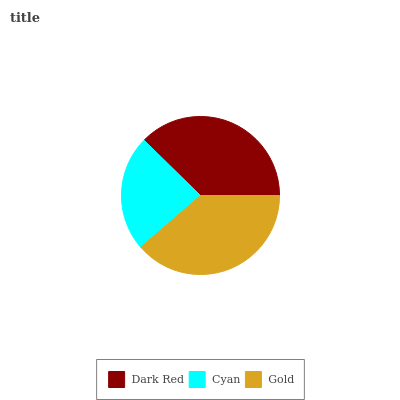Is Cyan the minimum?
Answer yes or no. Yes. Is Gold the maximum?
Answer yes or no. Yes. Is Gold the minimum?
Answer yes or no. No. Is Cyan the maximum?
Answer yes or no. No. Is Gold greater than Cyan?
Answer yes or no. Yes. Is Cyan less than Gold?
Answer yes or no. Yes. Is Cyan greater than Gold?
Answer yes or no. No. Is Gold less than Cyan?
Answer yes or no. No. Is Dark Red the high median?
Answer yes or no. Yes. Is Dark Red the low median?
Answer yes or no. Yes. Is Gold the high median?
Answer yes or no. No. Is Cyan the low median?
Answer yes or no. No. 